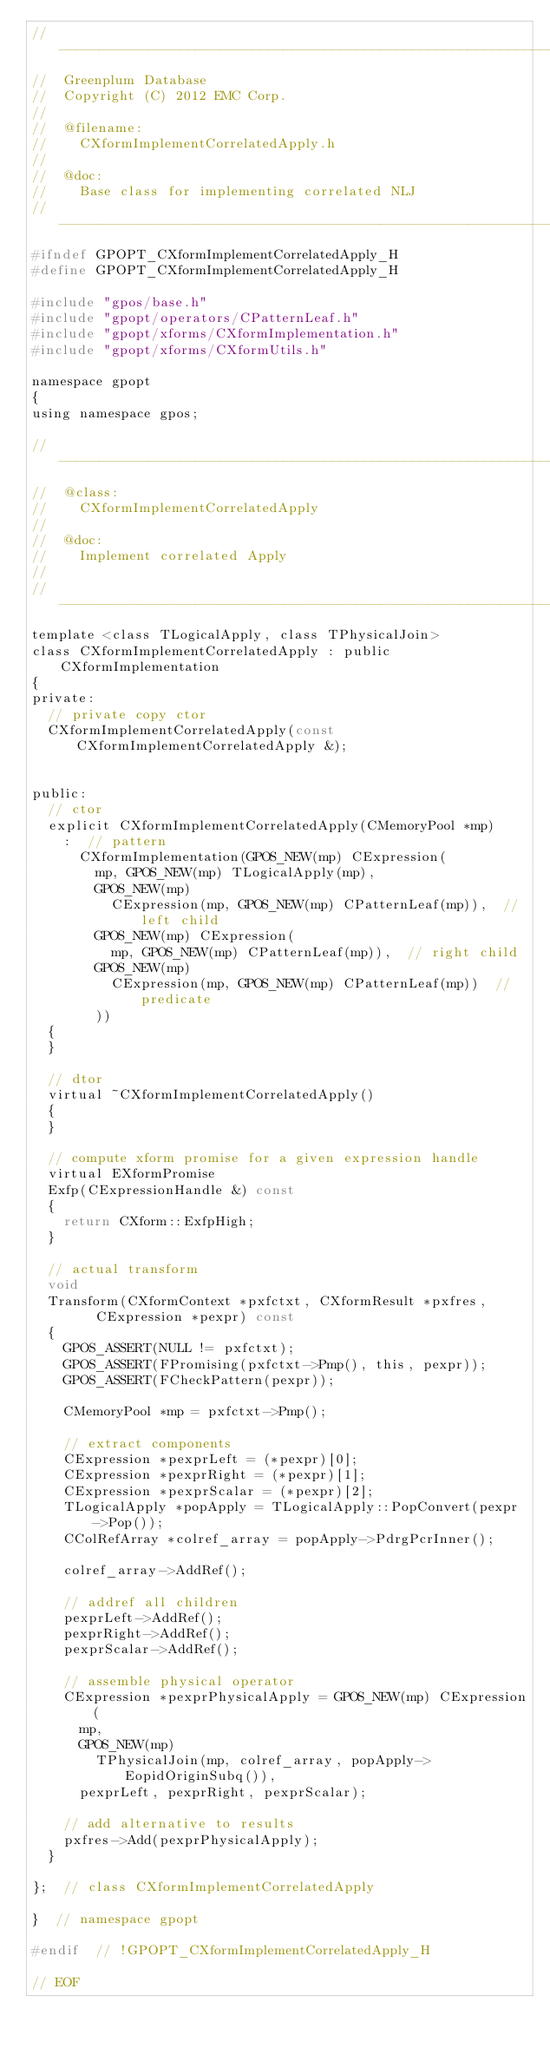Convert code to text. <code><loc_0><loc_0><loc_500><loc_500><_C_>//---------------------------------------------------------------------------
//	Greenplum Database
//	Copyright (C) 2012 EMC Corp.
//
//	@filename:
//		CXformImplementCorrelatedApply.h
//
//	@doc:
//		Base class for implementing correlated NLJ
//---------------------------------------------------------------------------
#ifndef GPOPT_CXformImplementCorrelatedApply_H
#define GPOPT_CXformImplementCorrelatedApply_H

#include "gpos/base.h"
#include "gpopt/operators/CPatternLeaf.h"
#include "gpopt/xforms/CXformImplementation.h"
#include "gpopt/xforms/CXformUtils.h"

namespace gpopt
{
using namespace gpos;

//---------------------------------------------------------------------------
//	@class:
//		CXformImplementCorrelatedApply
//
//	@doc:
//		Implement correlated Apply
//
//---------------------------------------------------------------------------
template <class TLogicalApply, class TPhysicalJoin>
class CXformImplementCorrelatedApply : public CXformImplementation
{
private:
	// private copy ctor
	CXformImplementCorrelatedApply(const CXformImplementCorrelatedApply &);


public:
	// ctor
	explicit CXformImplementCorrelatedApply(CMemoryPool *mp)
		:  // pattern
		  CXformImplementation(GPOS_NEW(mp) CExpression(
			  mp, GPOS_NEW(mp) TLogicalApply(mp),
			  GPOS_NEW(mp)
				  CExpression(mp, GPOS_NEW(mp) CPatternLeaf(mp)),  // left child
			  GPOS_NEW(mp) CExpression(
				  mp, GPOS_NEW(mp) CPatternLeaf(mp)),  // right child
			  GPOS_NEW(mp)
				  CExpression(mp, GPOS_NEW(mp) CPatternLeaf(mp))  // predicate
			  ))
	{
	}

	// dtor
	virtual ~CXformImplementCorrelatedApply()
	{
	}

	// compute xform promise for a given expression handle
	virtual EXformPromise
	Exfp(CExpressionHandle &) const
	{
		return CXform::ExfpHigh;
	}

	// actual transform
	void
	Transform(CXformContext *pxfctxt, CXformResult *pxfres,
			  CExpression *pexpr) const
	{
		GPOS_ASSERT(NULL != pxfctxt);
		GPOS_ASSERT(FPromising(pxfctxt->Pmp(), this, pexpr));
		GPOS_ASSERT(FCheckPattern(pexpr));

		CMemoryPool *mp = pxfctxt->Pmp();

		// extract components
		CExpression *pexprLeft = (*pexpr)[0];
		CExpression *pexprRight = (*pexpr)[1];
		CExpression *pexprScalar = (*pexpr)[2];
		TLogicalApply *popApply = TLogicalApply::PopConvert(pexpr->Pop());
		CColRefArray *colref_array = popApply->PdrgPcrInner();

		colref_array->AddRef();

		// addref all children
		pexprLeft->AddRef();
		pexprRight->AddRef();
		pexprScalar->AddRef();

		// assemble physical operator
		CExpression *pexprPhysicalApply = GPOS_NEW(mp) CExpression(
			mp,
			GPOS_NEW(mp)
				TPhysicalJoin(mp, colref_array, popApply->EopidOriginSubq()),
			pexprLeft, pexprRight, pexprScalar);

		// add alternative to results
		pxfres->Add(pexprPhysicalApply);
	}

};	// class CXformImplementCorrelatedApply

}  // namespace gpopt

#endif	// !GPOPT_CXformImplementCorrelatedApply_H

// EOF
</code> 